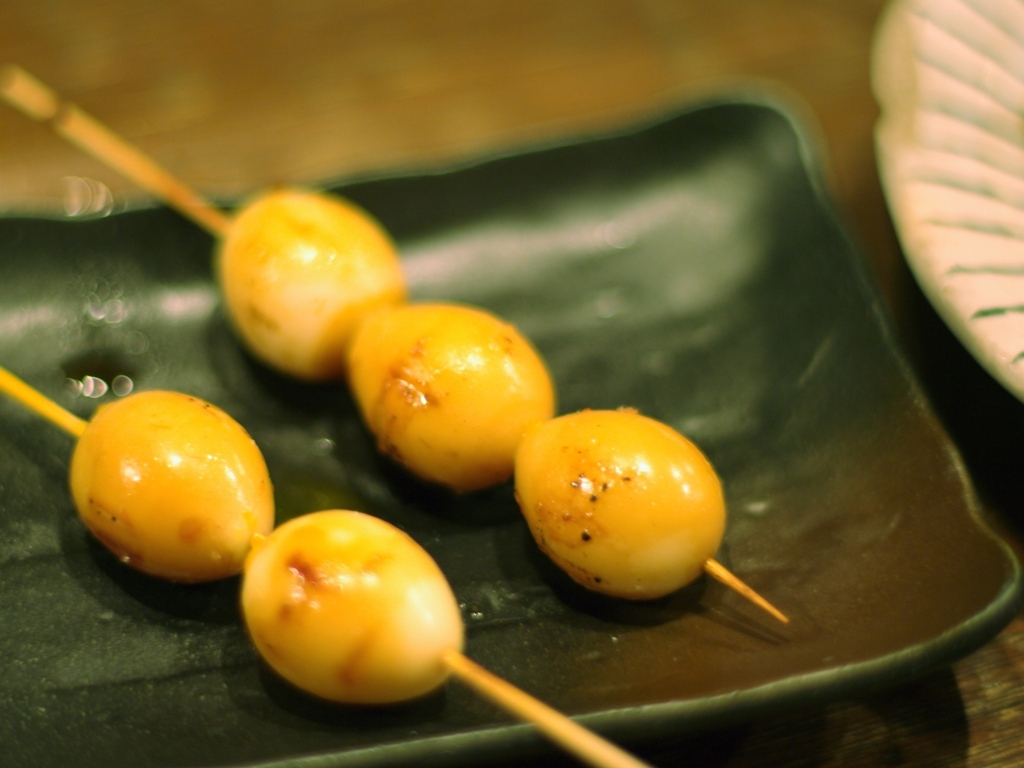What kind of food is presented in the image, and is it a common dish in some parts of the world? The image shows skewered food items that appear to be some sort of grilled balls, which could be takoyaki, a popular Japanese street food often filled with minced or diced octopus. Takoyaki is indeed a common and beloved dish in Japan and has gained international popularity. 